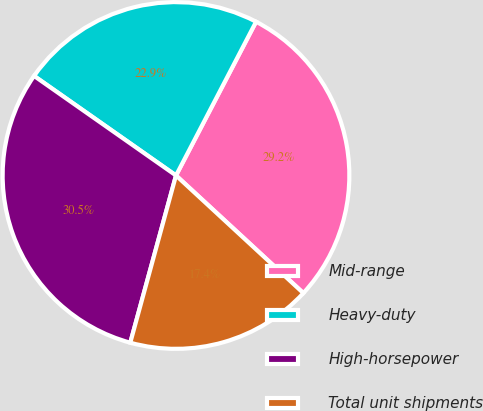<chart> <loc_0><loc_0><loc_500><loc_500><pie_chart><fcel>Mid-range<fcel>Heavy-duty<fcel>High-horsepower<fcel>Total unit shipments<nl><fcel>29.23%<fcel>22.91%<fcel>30.49%<fcel>17.38%<nl></chart> 